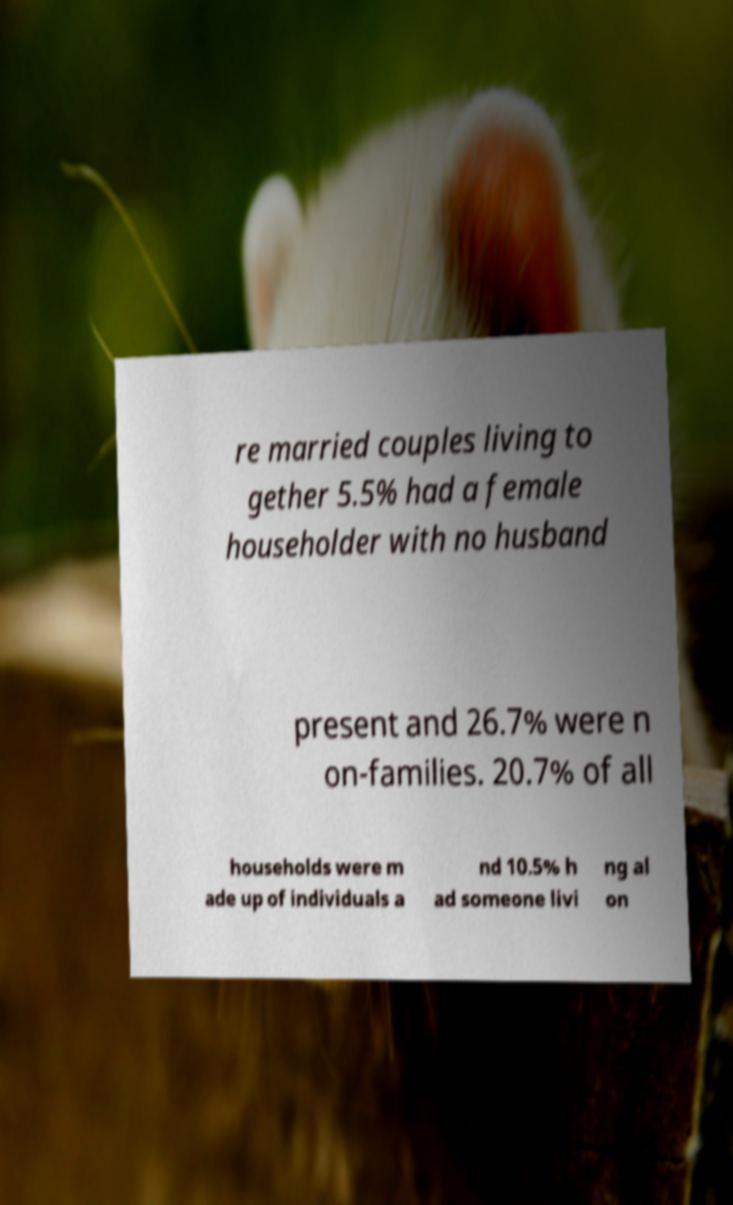Please identify and transcribe the text found in this image. re married couples living to gether 5.5% had a female householder with no husband present and 26.7% were n on-families. 20.7% of all households were m ade up of individuals a nd 10.5% h ad someone livi ng al on 